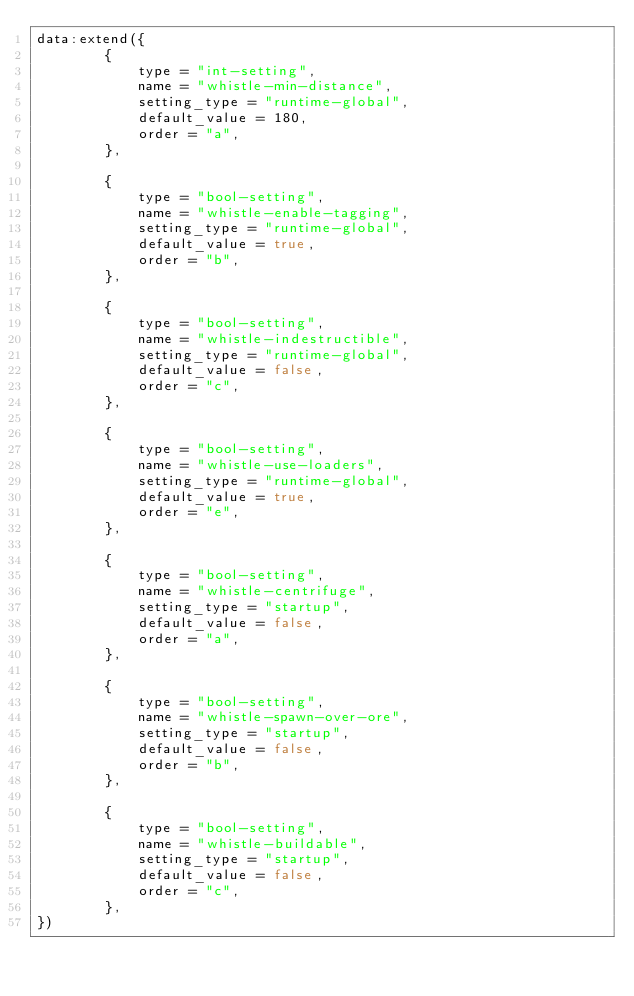Convert code to text. <code><loc_0><loc_0><loc_500><loc_500><_Lua_>data:extend({
        {
            type = "int-setting",
            name = "whistle-min-distance",
            setting_type = "runtime-global",
            default_value = 180,
            order = "a",
        },

        {
            type = "bool-setting",
            name = "whistle-enable-tagging",
            setting_type = "runtime-global",
            default_value = true,
            order = "b",
        },

        {
            type = "bool-setting",
            name = "whistle-indestructible",
            setting_type = "runtime-global",
            default_value = false,
            order = "c",
        },

        {
            type = "bool-setting",
            name = "whistle-use-loaders",
            setting_type = "runtime-global",
            default_value = true,
            order = "e",
        },

        {
            type = "bool-setting",
            name = "whistle-centrifuge",
            setting_type = "startup",
            default_value = false,
            order = "a",
        },

        {
            type = "bool-setting",
            name = "whistle-spawn-over-ore",
            setting_type = "startup",
            default_value = false,
            order = "b",
        },

        {
            type = "bool-setting",
            name = "whistle-buildable",
            setting_type = "startup",
            default_value = false,
            order = "c",
        },
})
</code> 